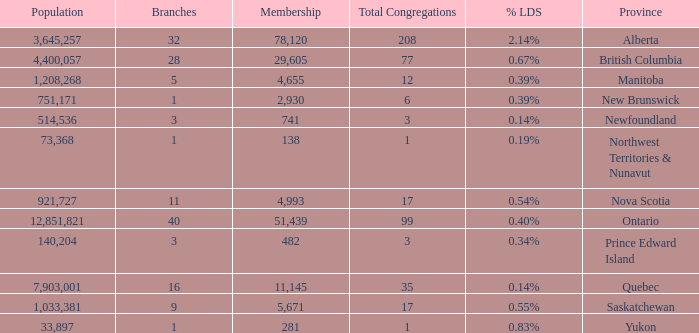I'm looking to parse the entire table for insights. Could you assist me with that? {'header': ['Population', 'Branches', 'Membership', 'Total Congregations', '% LDS', 'Province'], 'rows': [['3,645,257', '32', '78,120', '208', '2.14%', 'Alberta'], ['4,400,057', '28', '29,605', '77', '0.67%', 'British Columbia'], ['1,208,268', '5', '4,655', '12', '0.39%', 'Manitoba'], ['751,171', '1', '2,930', '6', '0.39%', 'New Brunswick'], ['514,536', '3', '741', '3', '0.14%', 'Newfoundland'], ['73,368', '1', '138', '1', '0.19%', 'Northwest Territories & Nunavut'], ['921,727', '11', '4,993', '17', '0.54%', 'Nova Scotia'], ['12,851,821', '40', '51,439', '99', '0.40%', 'Ontario'], ['140,204', '3', '482', '3', '0.34%', 'Prince Edward Island'], ['7,903,001', '16', '11,145', '35', '0.14%', 'Quebec'], ['1,033,381', '9', '5,671', '17', '0.55%', 'Saskatchewan'], ['33,897', '1', '281', '1', '0.83%', 'Yukon']]} What's the fewest number of branches with more than 1 total congregations, a population of 1,033,381, and a membership smaller than 5,671? None. 